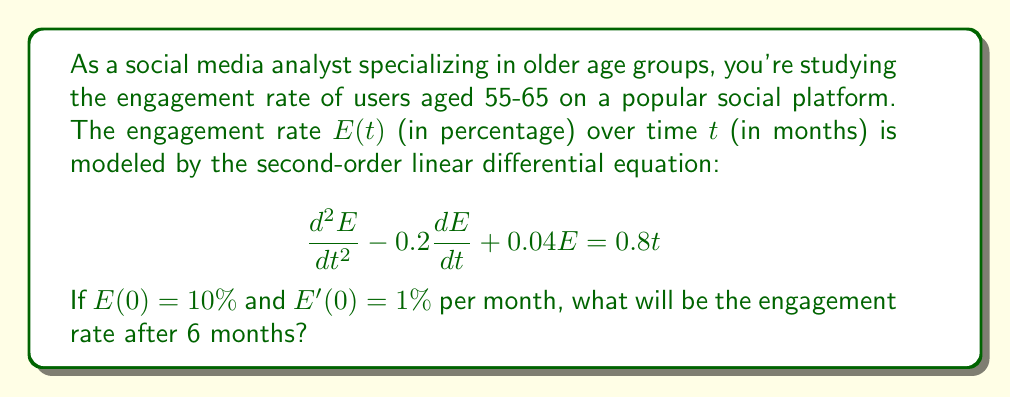Can you solve this math problem? To solve this problem, we'll follow these steps:

1) The general solution to this non-homogeneous second-order linear differential equation is:

   $E(t) = E_h(t) + E_p(t)$

   where $E_h(t)$ is the solution to the homogeneous equation and $E_p(t)$ is a particular solution.

2) For the homogeneous part, we solve:

   $\frac{d^2E}{dt^2} - 0.2\frac{dE}{dt} + 0.04E = 0$

   The characteristic equation is $r^2 - 0.2r + 0.04 = 0$
   Solving this: $r = 0.1 \pm 0.1 = 0.2$ or $0$

   So, $E_h(t) = c_1e^{0.2t} + c_2$

3) For the particular solution, we guess:

   $E_p(t) = At + B$

   Substituting this into the original equation:
   $0 - 0.2A + 0.04(At + B) = 0.8t$

   Equating coefficients:
   $0.04A = 0.8$, so $A = 20$
   $-0.2A + 0.04B = 0$, so $B = 100$

   Therefore, $E_p(t) = 20t + 100$

4) The general solution is:

   $E(t) = c_1e^{0.2t} + c_2 + 20t + 100$

5) Using the initial conditions:

   $E(0) = 10$, so $c_1 + c_2 + 100 = 10$
   $E'(0) = 1$, so $0.2c_1 + 20 = 1$

   Solving these: $c_1 = -95$ and $c_2 = 5$

6) Therefore, the particular solution is:

   $E(t) = -95e^{0.2t} + 5 + 20t + 100$

7) To find $E(6)$, we substitute $t = 6$:

   $E(6) = -95e^{1.2} + 5 + 120 + 100$
   $\approx -95(3.3201) + 225$
   $\approx 109.59\%$
Answer: 109.59% 